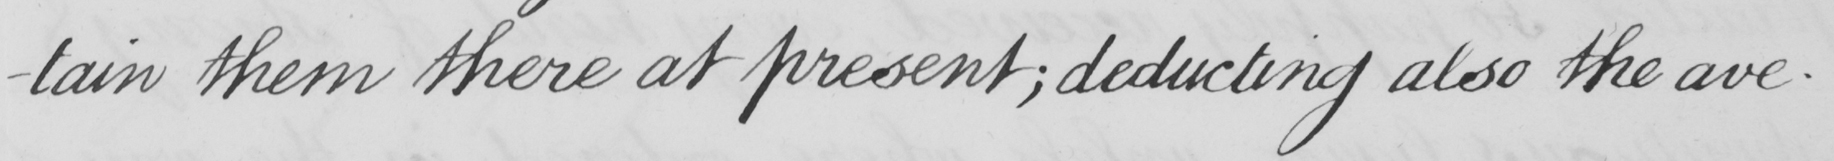What text is written in this handwritten line? -tain them there at present ; deducting also the ave- 